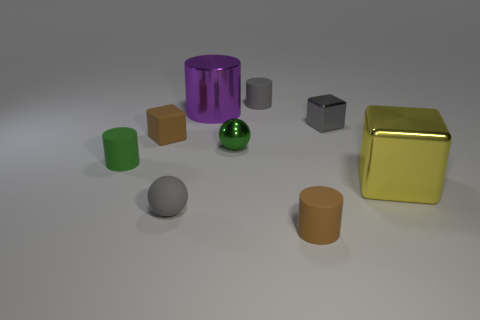Subtract all yellow cylinders. Subtract all brown blocks. How many cylinders are left? 4 Add 1 cyan matte objects. How many objects exist? 10 Subtract all blocks. How many objects are left? 6 Subtract all large green balls. Subtract all big metal objects. How many objects are left? 7 Add 7 tiny rubber cylinders. How many tiny rubber cylinders are left? 10 Add 8 big yellow matte blocks. How many big yellow matte blocks exist? 8 Subtract 0 blue cubes. How many objects are left? 9 